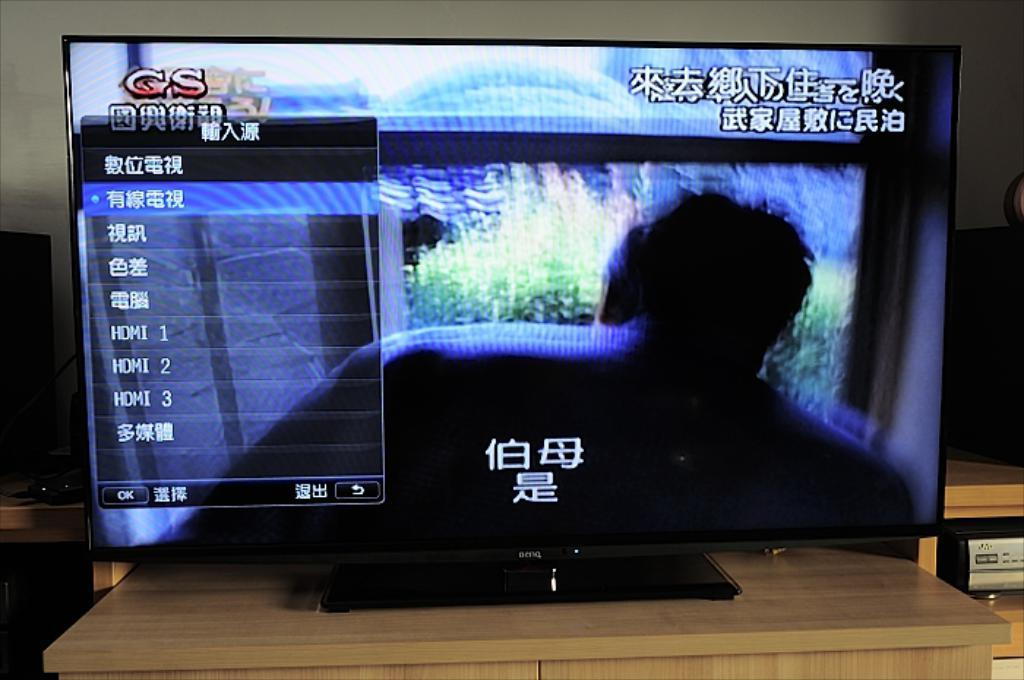<image>
Share a concise interpretation of the image provided. The screen shown has the letters GS on the top left. 